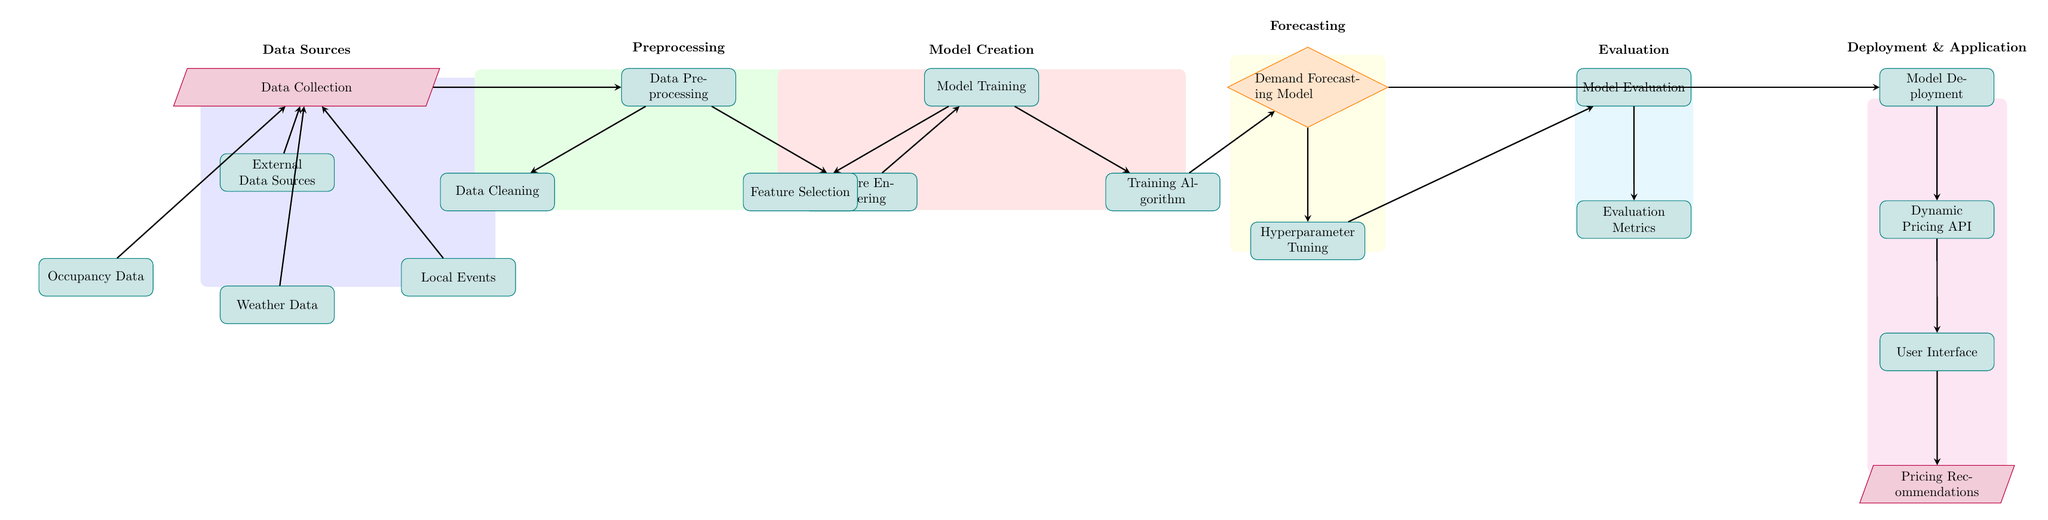What is the first node in the diagram? The first node, which represents the initial step in the process, is "Data Collection." It is the entry point to gather data needed for the model.
Answer: Data Collection How many types of data sources are included in the diagram? The diagram lists four types of data sources: External Data Sources, Occupancy Data, Weather Data, and Local Events. By counting these nodes, we find the total.
Answer: Four Which process follows Data Preprocessing? According to the flow of the diagram, the node directly following Data Preprocessing is Model Training, which indicates the next step after cleaning and preparing the data.
Answer: Model Training What is the purpose of the Demand Forecasting Model? The Demand Forecasting Model is central to the workflow as it predicts future demand based on the processed data, which is critical for implementing a dynamic pricing strategy.
Answer: Predict future demand What is the relationship between Model Evaluation and Model Deployment? The diagram shows an arrow pointing from Model Evaluation to Model Deployment, indicating that, after the model is evaluated and deemed satisfactory, it proceeds to the deployment phase where it is made operational.
Answer: Sequential steps Which process involves modifying hyperparameters? The diagram clearly shows that Hyperparameter Tuning is the process involved in adjusting the model's hyperparameters to optimize its performance before deployment.
Answer: Hyperparameter Tuning What are the Evaluation Metrics used for? The Evaluation Metrics are used to assess the performance of the model after training and tuning, determining how well the model predicts demand and its effectiveness.
Answer: Assess model performance Which component outputs Pricing Recommendations? The User Interface component is the final node in the diagram that outputs Pricing Recommendations, displaying the suggested prices based on the forecasts generated by the Demand Forecasting Model.
Answer: User Interface 